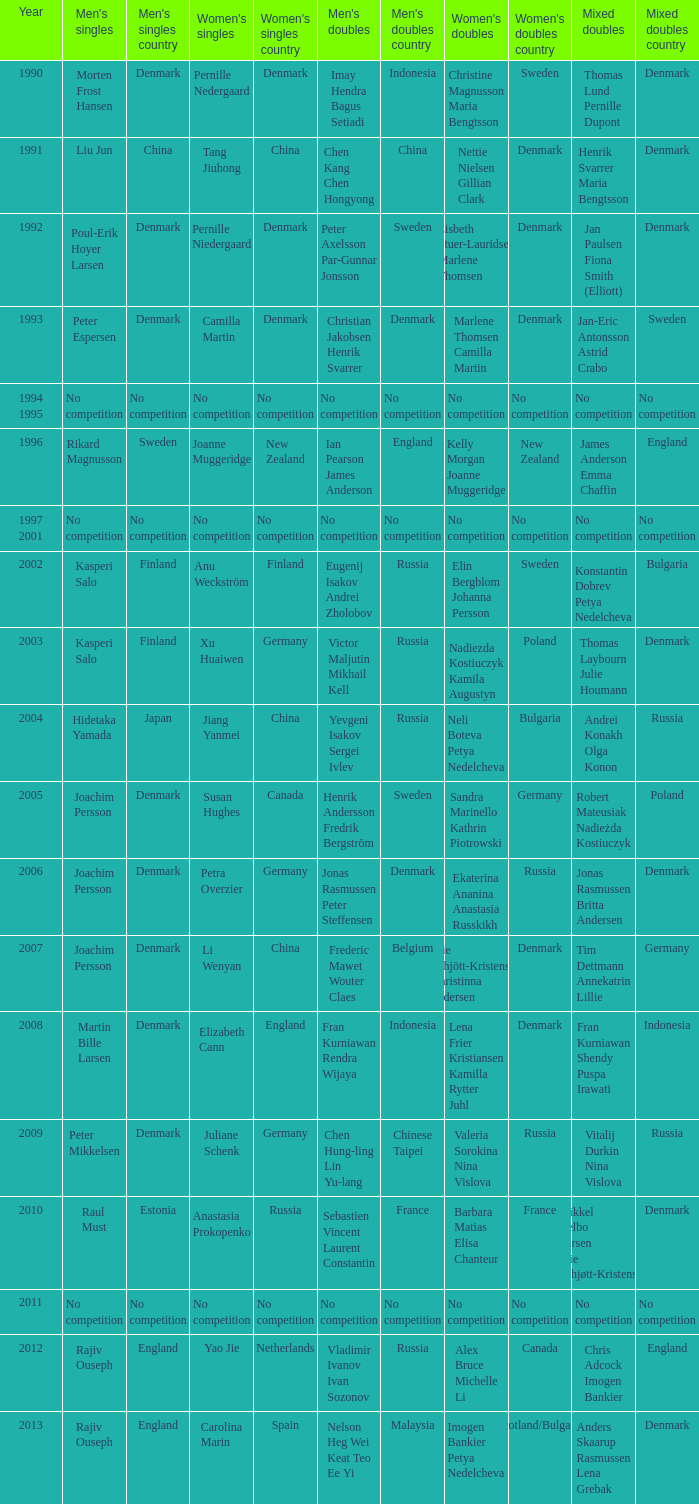I'm looking to parse the entire table for insights. Could you assist me with that? {'header': ['Year', "Men's singles", "Men's singles country", "Women's singles", "Women's singles country", "Men's doubles", "Men's doubles country", "Women's doubles", "Women's doubles country", 'Mixed doubles', 'Mixed doubles country'], 'rows': [['1990', 'Morten Frost Hansen', 'Denmark', 'Pernille Nedergaard', 'Denmark', 'Imay Hendra Bagus Setiadi', 'Indonesia', 'Christine Magnusson Maria Bengtsson', 'Sweden', 'Thomas Lund Pernille Dupont', 'Denmark'], ['1991', 'Liu Jun', 'China', 'Tang Jiuhong', 'China', 'Chen Kang Chen Hongyong', 'China', 'Nettie Nielsen Gillian Clark', 'Denmark', 'Henrik Svarrer Maria Bengtsson', 'Denmark'], ['1992', 'Poul-Erik Hoyer Larsen', 'Denmark', 'Pernille Niedergaard', 'Denmark', 'Peter Axelsson Par-Gunnar Jonsson', 'Sweden', 'Lisbeth Stuer-Lauridsen Marlene Thomsen', 'Denmark', 'Jan Paulsen Fiona Smith (Elliott)', 'Denmark'], ['1993', 'Peter Espersen', 'Denmark', 'Camilla Martin', 'Denmark', 'Christian Jakobsen Henrik Svarrer', 'Denmark', 'Marlene Thomsen Camilla Martin', 'Denmark', 'Jan-Eric Antonsson Astrid Crabo', 'Sweden'], ['1994 1995', 'No competition', 'No competition', 'No competition', 'No competition', 'No competition', 'No competition', 'No competition', 'No competition', 'No competition', 'No competition'], ['1996', 'Rikard Magnusson', 'Sweden', 'Joanne Muggeridge', 'New Zealand', 'Ian Pearson James Anderson', 'England', 'Kelly Morgan Joanne Muggeridge', 'New Zealand', 'James Anderson Emma Chaffin', 'England'], ['1997 2001', 'No competition', 'No competition', 'No competition', 'No competition', 'No competition', 'No competition', 'No competition', 'No competition', 'No competition', 'No competition'], ['2002', 'Kasperi Salo', 'Finland', 'Anu Weckström', 'Finland', 'Eugenij Isakov Andrei Zholobov', 'Russia', 'Elin Bergblom Johanna Persson', 'Sweden', 'Konstantin Dobrev Petya Nedelcheva', 'Bulgaria'], ['2003', 'Kasperi Salo', 'Finland', 'Xu Huaiwen', 'Germany', 'Victor Maljutin Mikhail Kell', 'Russia', 'Nadiezda Kostiuczyk Kamila Augustyn', 'Poland', 'Thomas Laybourn Julie Houmann', 'Denmark'], ['2004', 'Hidetaka Yamada', 'Japan', 'Jiang Yanmei', 'China', 'Yevgeni Isakov Sergei Ivlev', 'Russia', 'Neli Boteva Petya Nedelcheva', 'Bulgaria', 'Andrei Konakh Olga Konon', 'Russia'], ['2005', 'Joachim Persson', 'Denmark', 'Susan Hughes', 'Canada', 'Henrik Andersson Fredrik Bergström', 'Sweden', 'Sandra Marinello Kathrin Piotrowski', 'Germany', 'Robert Mateusiak Nadieżda Kostiuczyk', 'Poland'], ['2006', 'Joachim Persson', 'Denmark', 'Petra Overzier', 'Germany', 'Jonas Rasmussen Peter Steffensen', 'Denmark', 'Ekaterina Ananina Anastasia Russkikh', 'Russia', 'Jonas Rasmussen Britta Andersen', 'Denmark'], ['2007', 'Joachim Persson', 'Denmark', 'Li Wenyan', 'China', 'Frederic Mawet Wouter Claes', 'Belgium', 'Mie Schjött-Kristensen Christinna Pedersen', 'Denmark', 'Tim Dettmann Annekatrin Lillie', 'Germany'], ['2008', 'Martin Bille Larsen', 'Denmark', 'Elizabeth Cann', 'England', 'Fran Kurniawan Rendra Wijaya', 'Indonesia', 'Lena Frier Kristiansen Kamilla Rytter Juhl', 'Denmark', 'Fran Kurniawan Shendy Puspa Irawati', 'Indonesia'], ['2009', 'Peter Mikkelsen', 'Denmark', 'Juliane Schenk', 'Germany', 'Chen Hung-ling Lin Yu-lang', 'Chinese Taipei', 'Valeria Sorokina Nina Vislova', 'Russia', 'Vitalij Durkin Nina Vislova', 'Russia'], ['2010', 'Raul Must', 'Estonia', 'Anastasia Prokopenko', 'Russia', 'Sebastien Vincent Laurent Constantin', 'France', 'Barbara Matias Elisa Chanteur', 'France', 'Mikkel Delbo Larsen Mie Schjøtt-Kristensen', 'Denmark'], ['2011', 'No competition', 'No competition', 'No competition', 'No competition', 'No competition', 'No competition', 'No competition', 'No competition', 'No competition', 'No competition'], ['2012', 'Rajiv Ouseph', 'England', 'Yao Jie', 'Netherlands', 'Vladimir Ivanov Ivan Sozonov', 'Russia', 'Alex Bruce Michelle Li', 'Canada', 'Chris Adcock Imogen Bankier', 'England'], ['2013', 'Rajiv Ouseph', 'England', 'Carolina Marin', 'Spain', 'Nelson Heg Wei Keat Teo Ee Yi', 'Malaysia', 'Imogen Bankier Petya Nedelcheva', 'Scotland/Bulgaria', 'Anders Skaarup Rasmussen Lena Grebak', 'Denmark']]} Who claimed victory in the 2007 mixed doubles? Tim Dettmann Annekatrin Lillie. 